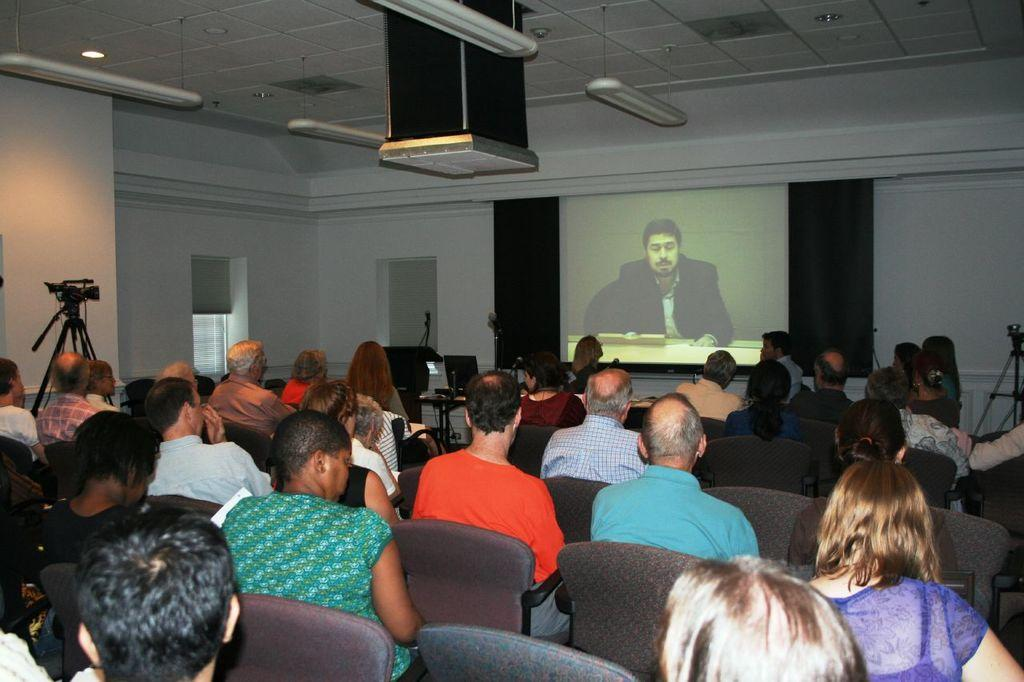How many people are in the image? There is a group of people in the image, but the exact number is not specified. What are the people doing in the image? The people are seated on chairs in the image. What objects are in front of the people? There are cameras and a projector screen in front of the people. What can be seen in the image that provides illumination? There are lights in the image. What type of temper can be seen in the dirt on the floor in the image? There is no dirt or temper present in the image. What is the cork used for in the image? There is no cork present in the image. 